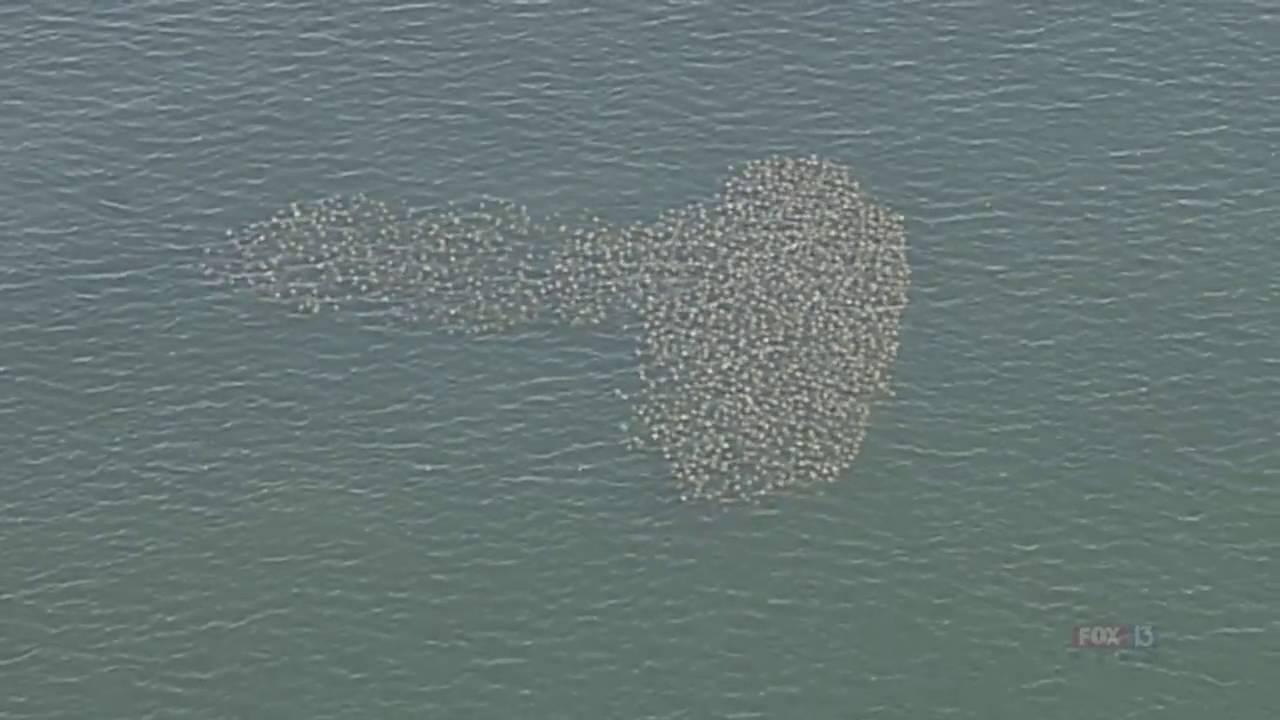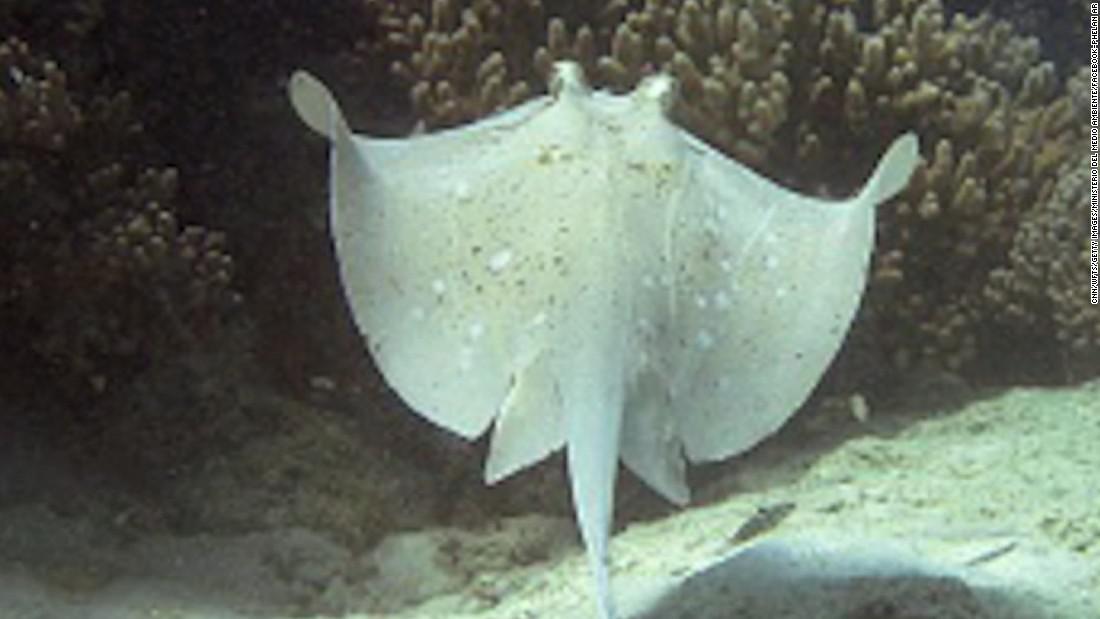The first image is the image on the left, the second image is the image on the right. Given the left and right images, does the statement "A single ray is shown in one of the images." hold true? Answer yes or no. Yes. 